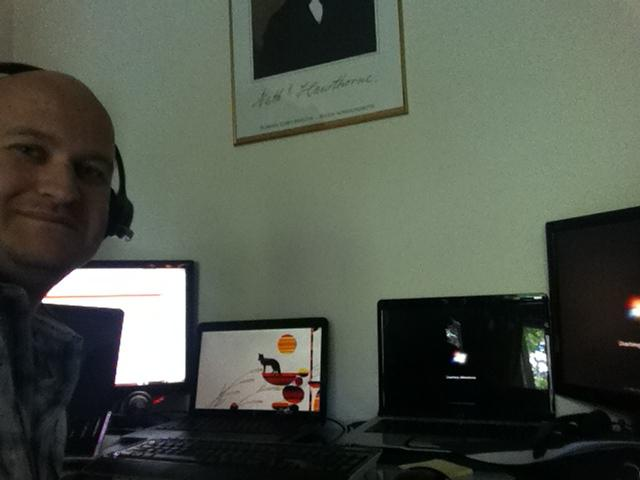What was installed on both the computers? Please explain your reasoning. windows. There is a logo that looks like a window. 